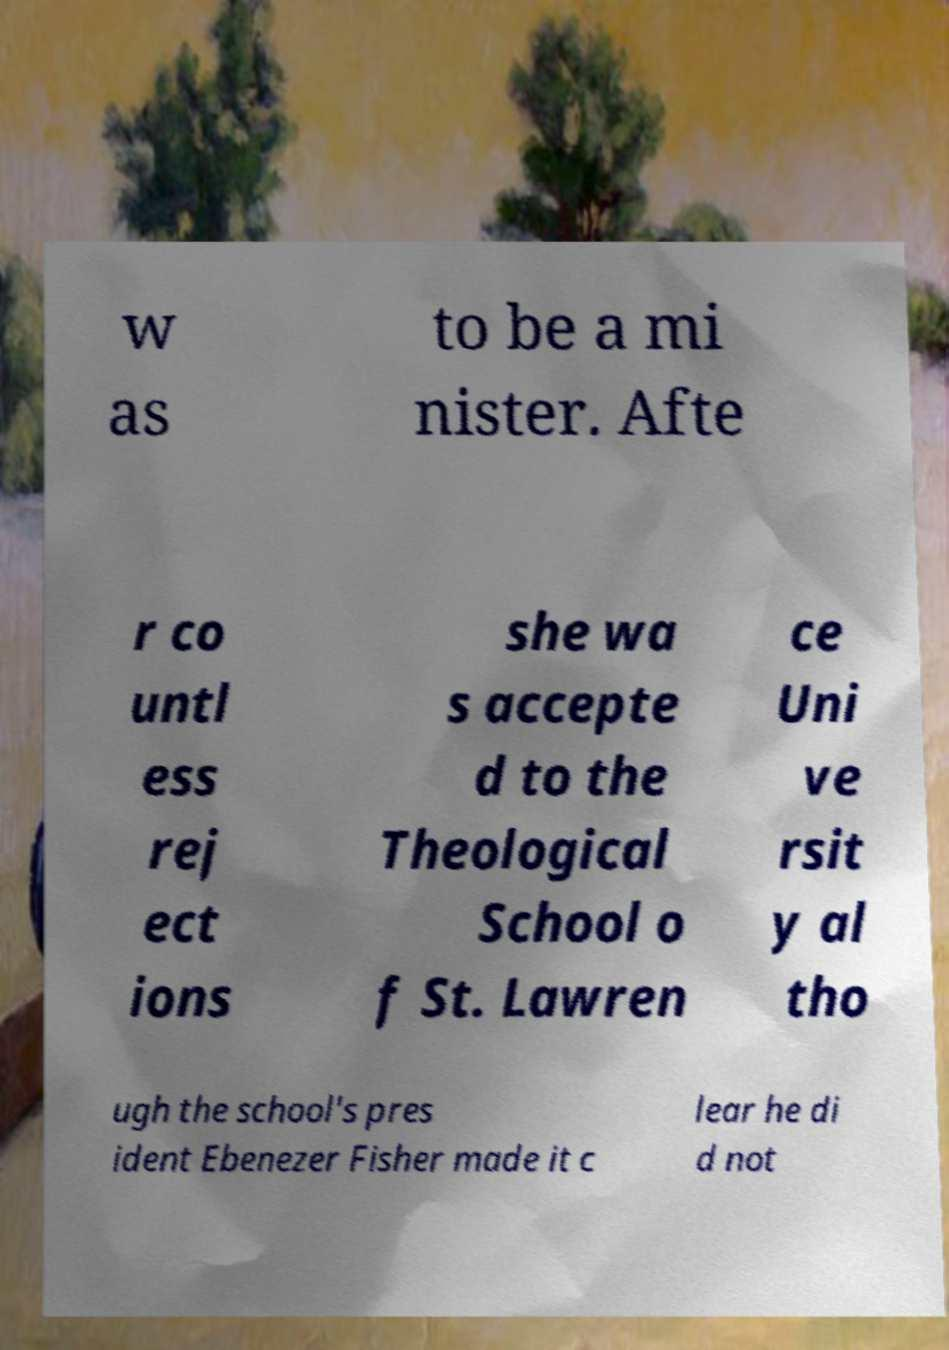Can you read and provide the text displayed in the image?This photo seems to have some interesting text. Can you extract and type it out for me? w as to be a mi nister. Afte r co untl ess rej ect ions she wa s accepte d to the Theological School o f St. Lawren ce Uni ve rsit y al tho ugh the school's pres ident Ebenezer Fisher made it c lear he di d not 